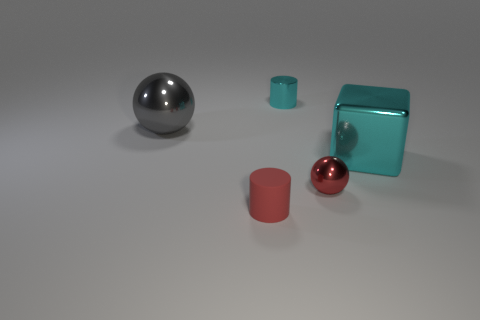What number of objects are small red matte cylinders or small cyan things? 2 